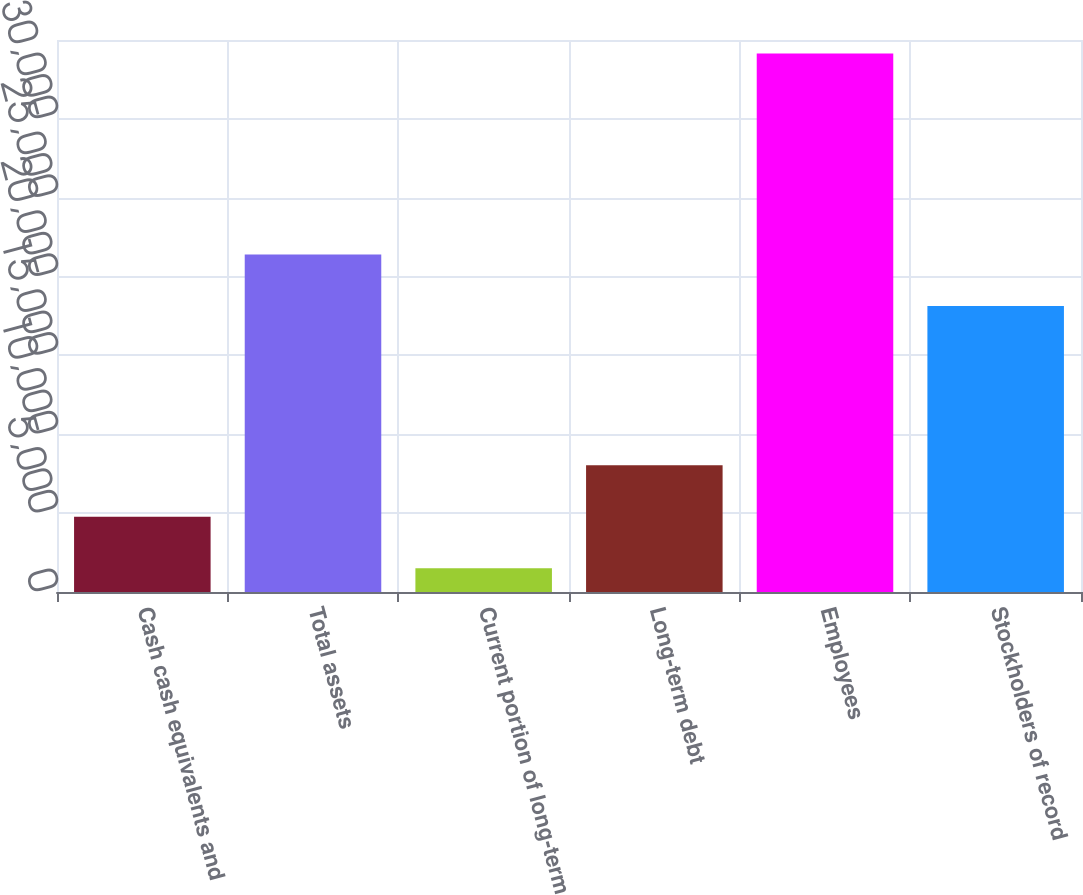<chart> <loc_0><loc_0><loc_500><loc_500><bar_chart><fcel>Cash cash equivalents and<fcel>Total assets<fcel>Current portion of long-term<fcel>Long-term debt<fcel>Employees<fcel>Stockholders of record<nl><fcel>4765.1<fcel>21393.1<fcel>1500<fcel>8030.2<fcel>34151<fcel>18128<nl></chart> 